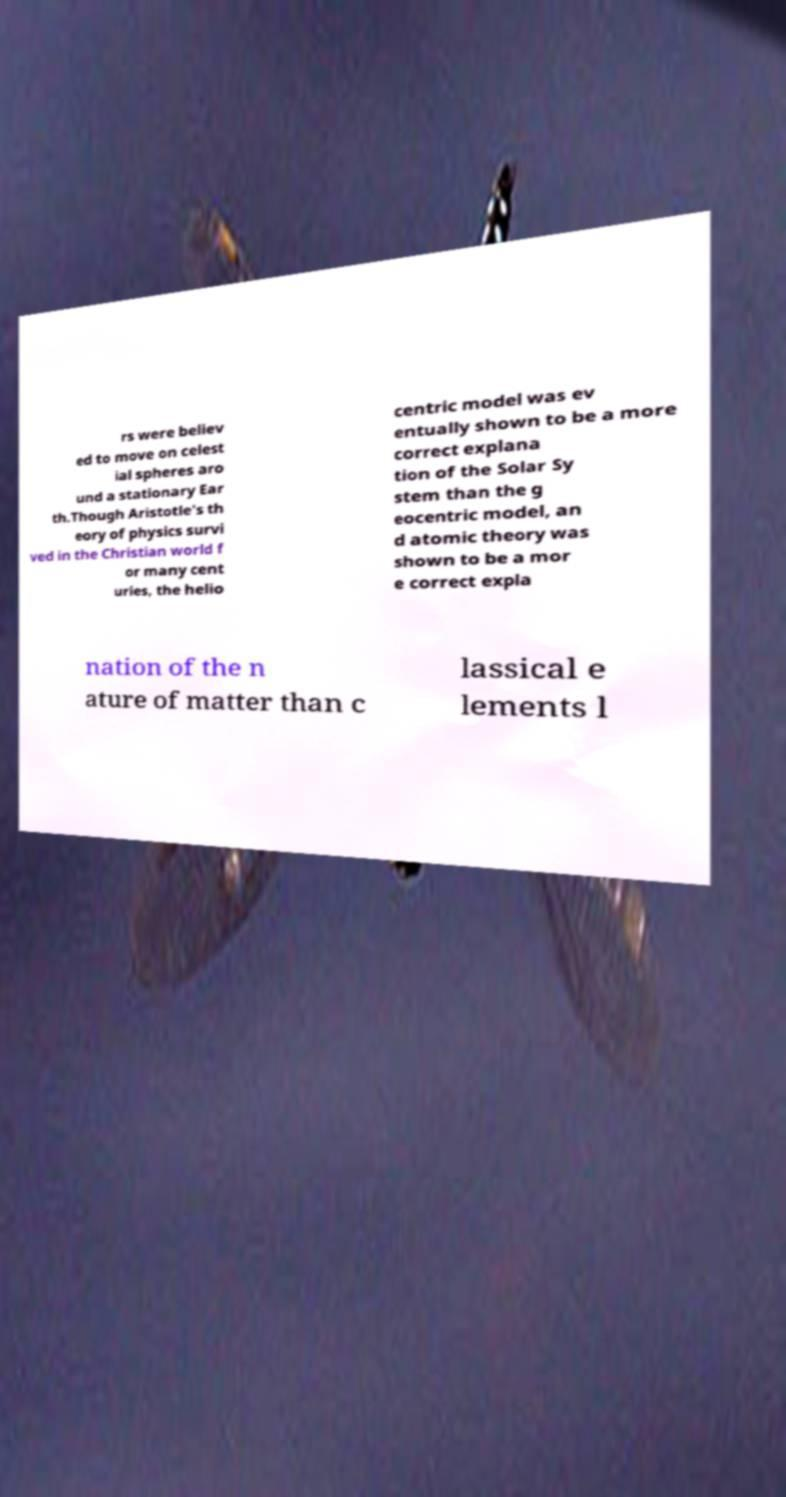Please identify and transcribe the text found in this image. rs were believ ed to move on celest ial spheres aro und a stationary Ear th.Though Aristotle's th eory of physics survi ved in the Christian world f or many cent uries, the helio centric model was ev entually shown to be a more correct explana tion of the Solar Sy stem than the g eocentric model, an d atomic theory was shown to be a mor e correct expla nation of the n ature of matter than c lassical e lements l 